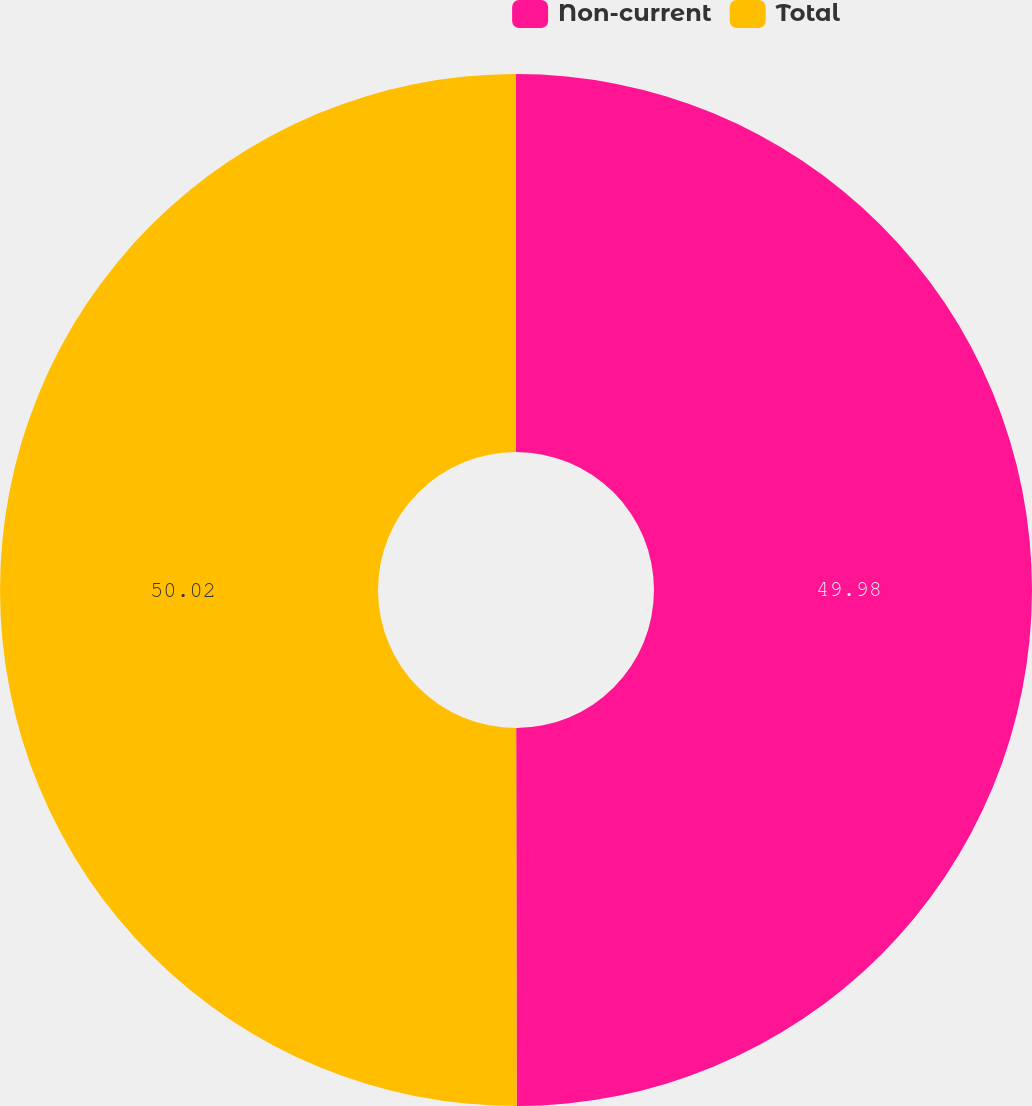<chart> <loc_0><loc_0><loc_500><loc_500><pie_chart><fcel>Non-current<fcel>Total<nl><fcel>49.98%<fcel>50.02%<nl></chart> 